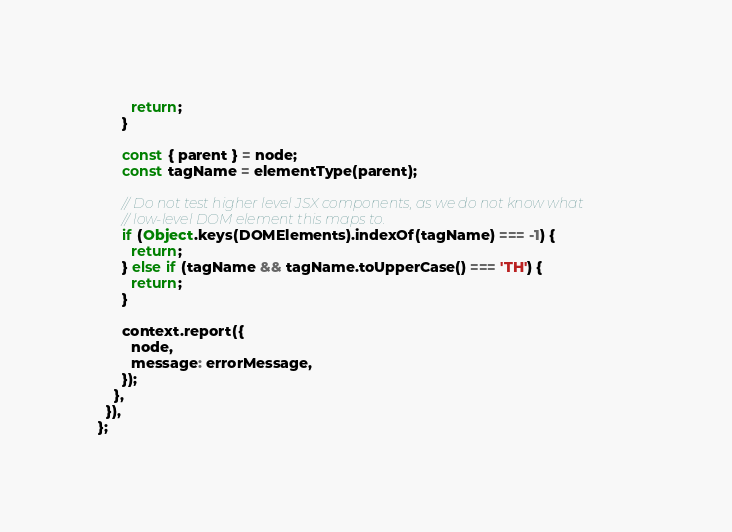Convert code to text. <code><loc_0><loc_0><loc_500><loc_500><_JavaScript_>        return;
      }

      const { parent } = node;
      const tagName = elementType(parent);

      // Do not test higher level JSX components, as we do not know what
      // low-level DOM element this maps to.
      if (Object.keys(DOMElements).indexOf(tagName) === -1) {
        return;
      } else if (tagName && tagName.toUpperCase() === 'TH') {
        return;
      }

      context.report({
        node,
        message: errorMessage,
      });
    },
  }),
};
</code> 